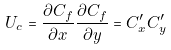<formula> <loc_0><loc_0><loc_500><loc_500>U _ { c } = \frac { \partial C _ { f } } { \partial x } \frac { \partial C _ { f } } { \partial y } = C _ { x } ^ { \prime } C _ { y } ^ { \prime }</formula> 